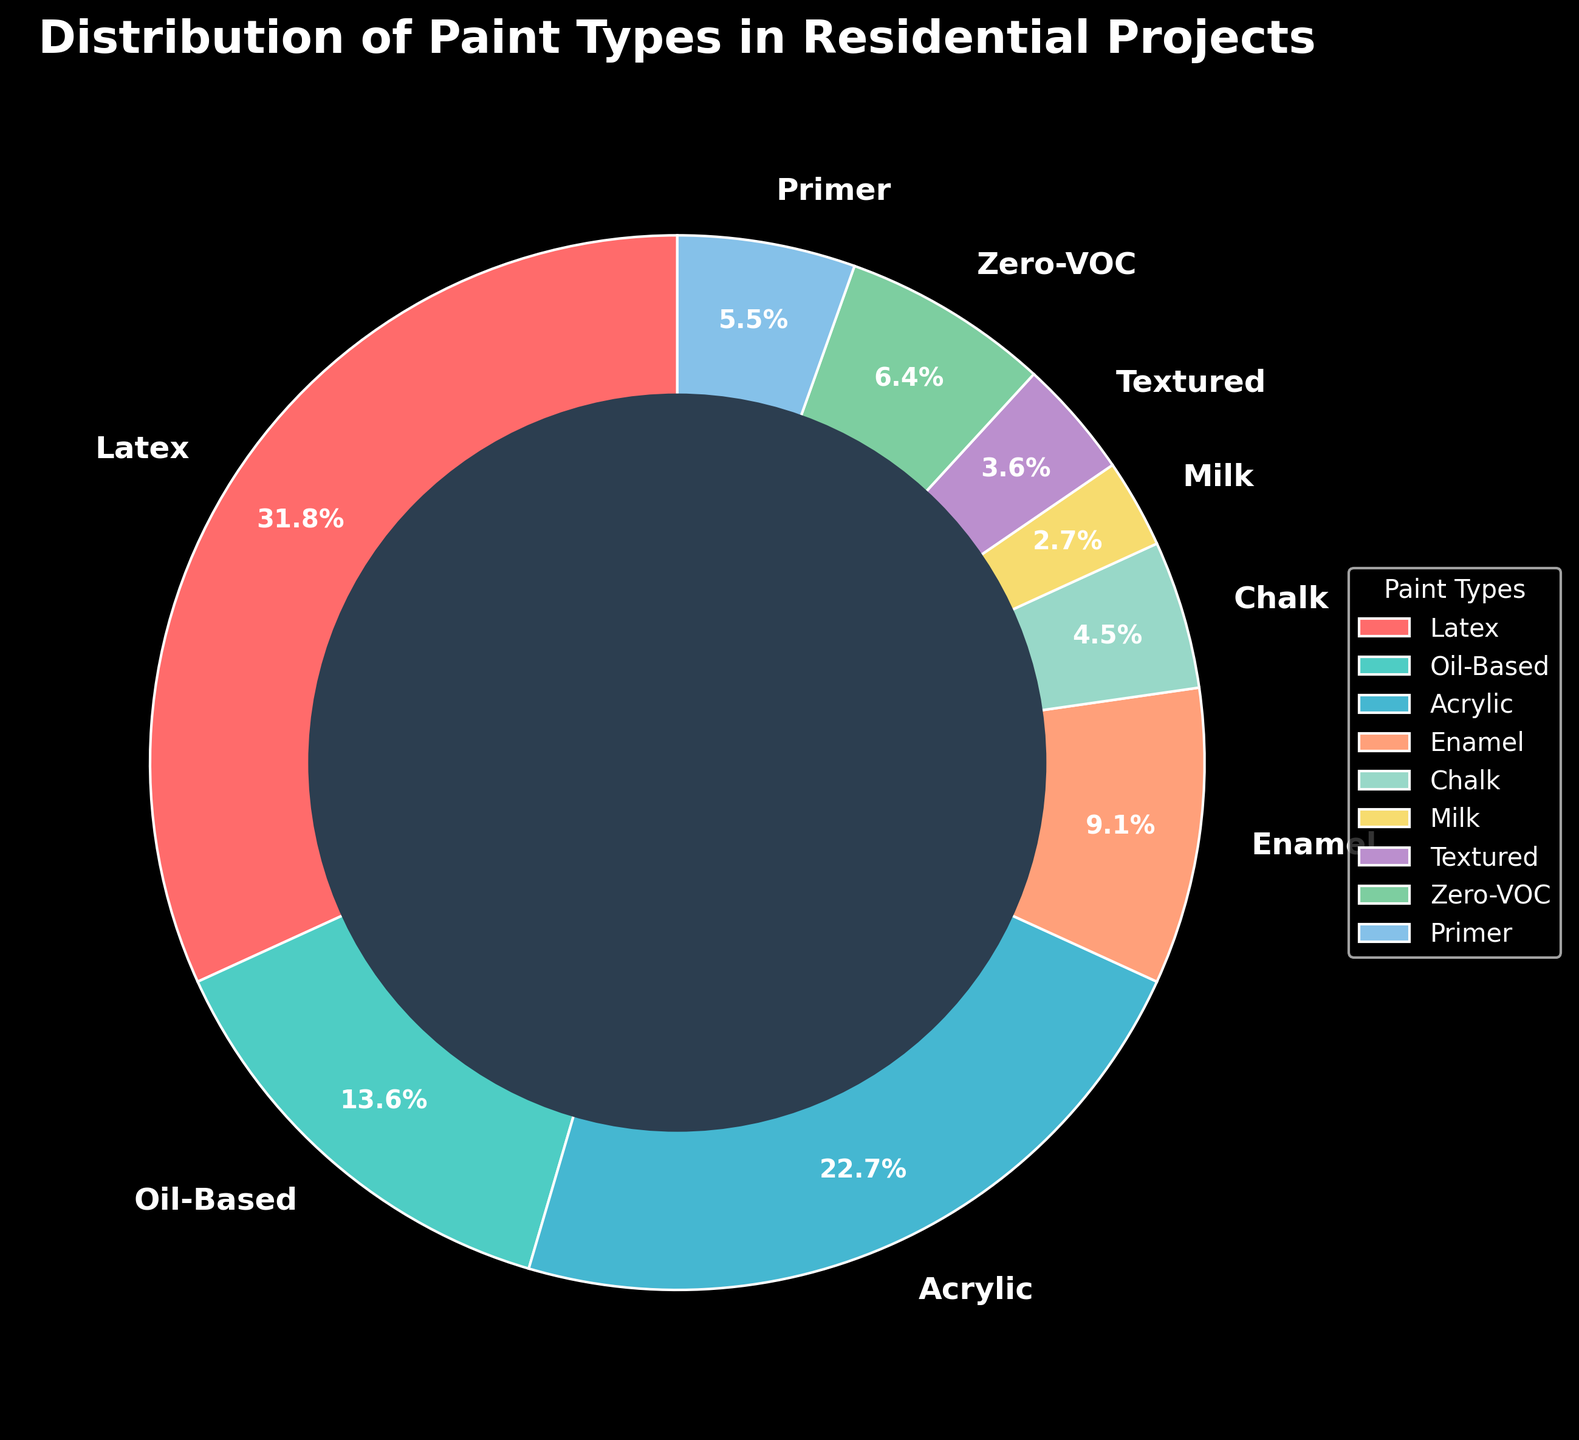What's the most commonly used paint type in residential projects? Look at the pie chart and identify which paint type has the largest slice. The largest percentage belongs to Latex paint.
Answer: Latex Which paint type is used the least in residential projects? Look at the pie chart and find the smallest slice. The smallest percentage belongs to Milk paint.
Answer: Milk What is the percentage difference between the most used paint type and the least used paint type? Identify the percentages for the most used (Latex, 35%) and least used (Milk, 3%) paint types. Subtract the smaller percentage from the larger one: 35% - 3% = 32%.
Answer: 32% How many paint types make up at least 10% of the total usage? Look at the pie chart and count slices equal to or greater than 10%. There are four paint types: Latex (35%), Acrylic (25%), Oil-Based (15%), and Enamel (10%).
Answer: 4 Which paint types contribute to less than 5% of the total usage combined? Identify paint types with less than 5% each: Chalk (5%), Milk (3%), Textured (4%), and Zero-VOC (7%). Add their percentages: 5% + 3% + 4% = 12%. Exclude Zero-VOC as it is 7%.
Answer: Chalk, Milk, Textured What is the combined percentage of Latex and Acrylic paint types? Sum the percentages of Latex (35%) and Acrylic (25%): 35% + 25% = 60%.
Answer: 60% How does the usage of Enamel paint compare to Primer paint? Look at the percentages for Enamel (10%) and Primer (6%). Enamel has a higher percentage: 10% > 6%.
Answer: Enamel > Primer What is the visual color used for the Oil-Based paint type slice? Identify the color associated with the Oil-Based paint type's slice in the pie chart. The slice is green.
Answer: Green What is the average percentage of Textured and Zero-VOC paint types? Calculate the average of the percentages for Textured (4%) and Zero-VOC (7%): (4% + 7%) / 2 = 5.5%.
Answer: 5.5% Which two paint types combined almost reach the same percentage as Latex paint? Identify the percentages for paint types and consider which two, when added, are close to 35% (Latex). Acrylic (25%) and Zero-VOC (7%) combined are close: 25% + 7% = 32%.
Answer: Acrylic and Zero-VOC 